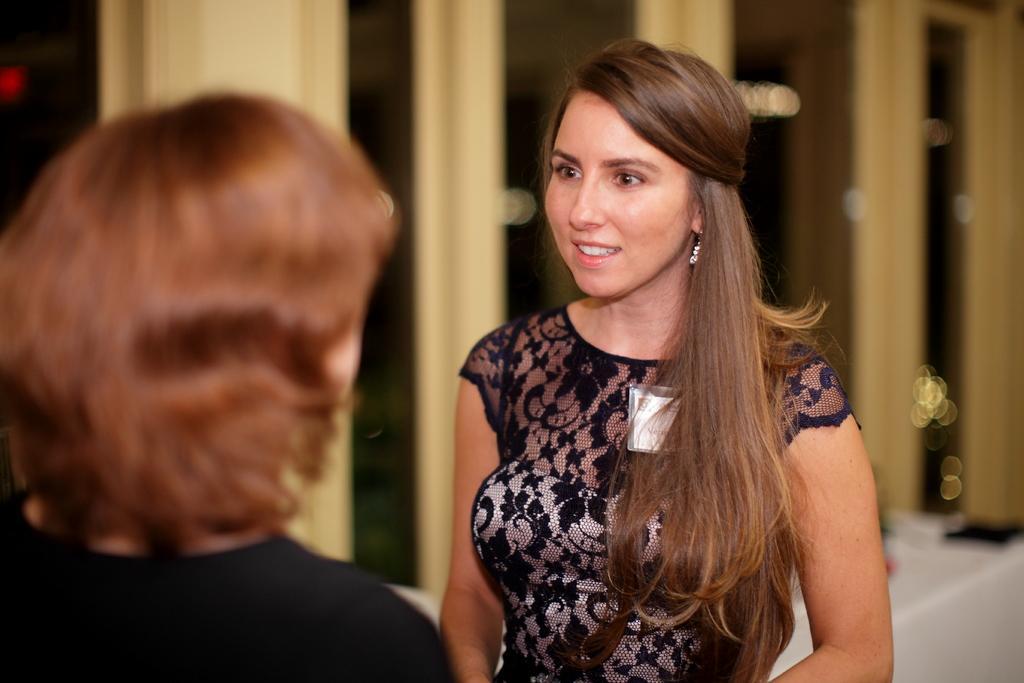Could you give a brief overview of what you see in this image? Here in this picture we can see two women standing on the floor over there and the woman in the middle is wearing black and silver colored dress on her and the woman on the left side is wearing total black colored dress on her over there. 